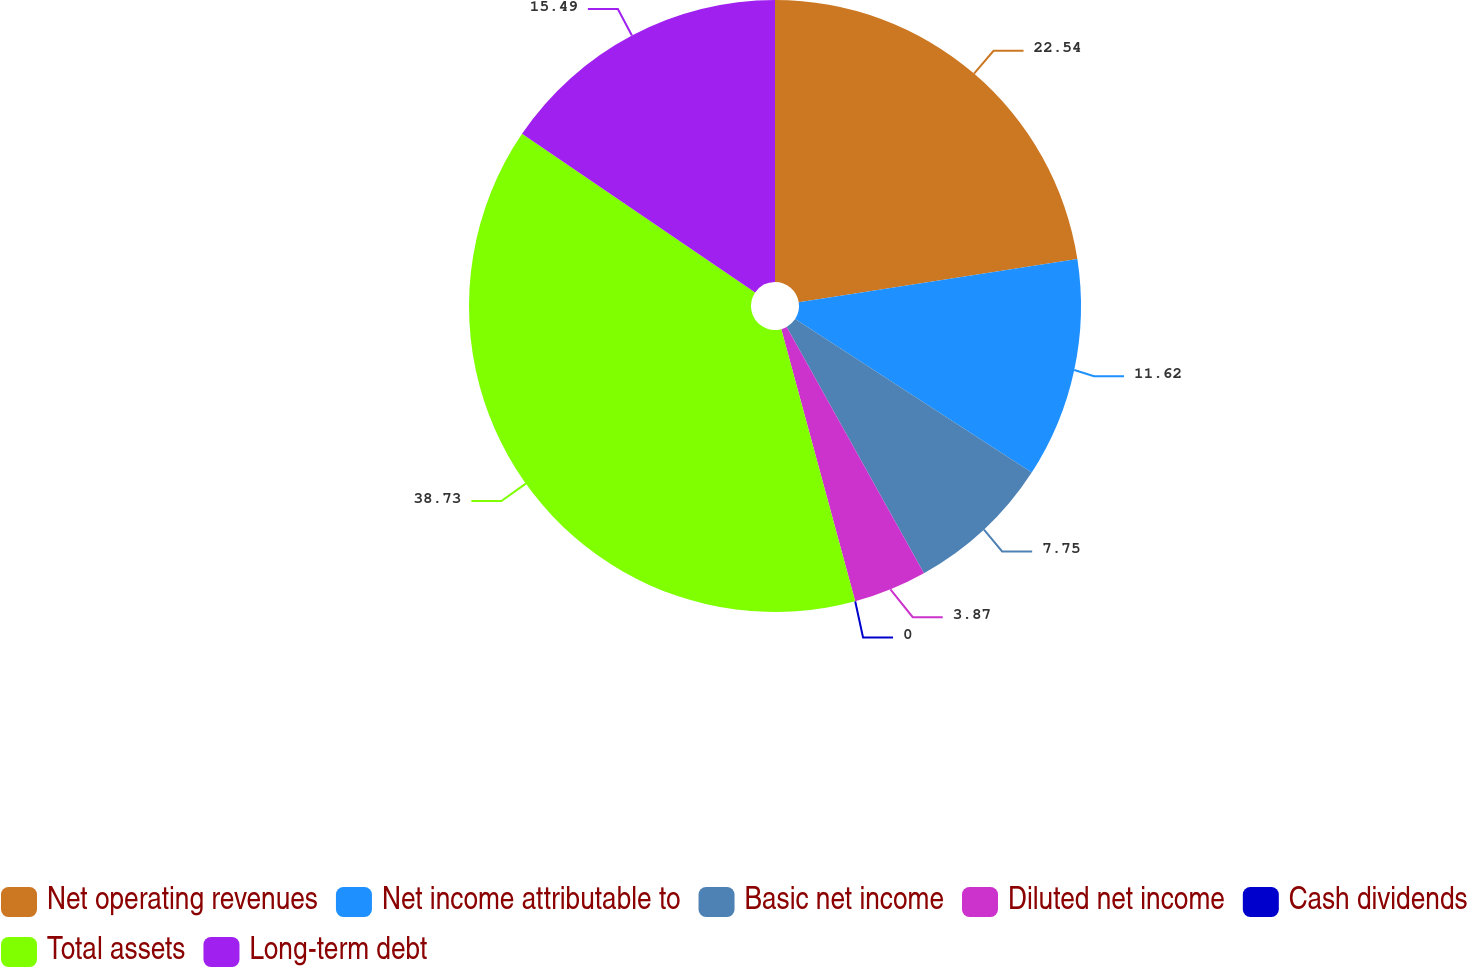Convert chart to OTSL. <chart><loc_0><loc_0><loc_500><loc_500><pie_chart><fcel>Net operating revenues<fcel>Net income attributable to<fcel>Basic net income<fcel>Diluted net income<fcel>Cash dividends<fcel>Total assets<fcel>Long-term debt<nl><fcel>22.54%<fcel>11.62%<fcel>7.75%<fcel>3.87%<fcel>0.0%<fcel>38.73%<fcel>15.49%<nl></chart> 